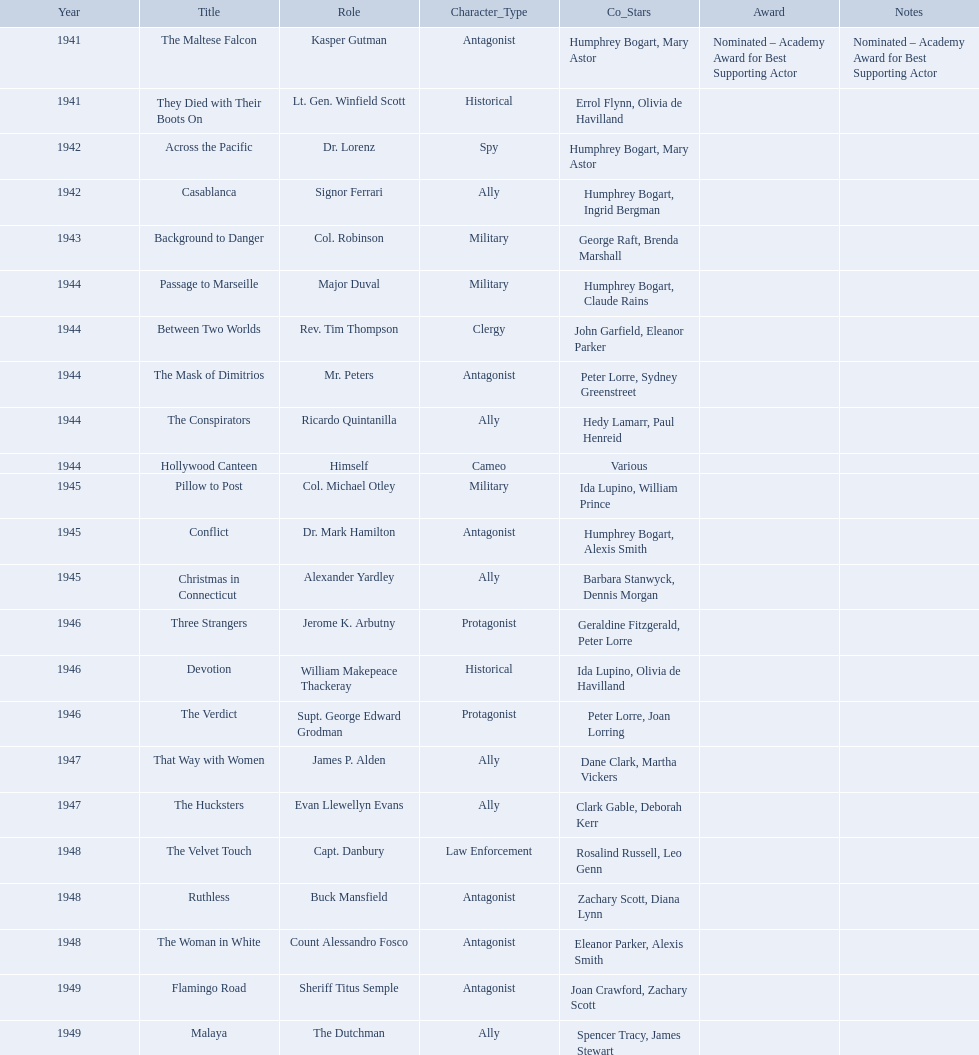What are all of the movies sydney greenstreet acted in? The Maltese Falcon, They Died with Their Boots On, Across the Pacific, Casablanca, Background to Danger, Passage to Marseille, Between Two Worlds, The Mask of Dimitrios, The Conspirators, Hollywood Canteen, Pillow to Post, Conflict, Christmas in Connecticut, Three Strangers, Devotion, The Verdict, That Way with Women, The Hucksters, The Velvet Touch, Ruthless, The Woman in White, Flamingo Road, Malaya. What are all of the title notes? Nominated – Academy Award for Best Supporting Actor. Could you parse the entire table? {'header': ['Year', 'Title', 'Role', 'Character_Type', 'Co_Stars', 'Award', 'Notes'], 'rows': [['1941', 'The Maltese Falcon', 'Kasper Gutman', 'Antagonist', 'Humphrey Bogart, Mary Astor', 'Nominated – Academy Award for Best Supporting Actor', 'Nominated – Academy Award for Best Supporting Actor'], ['1941', 'They Died with Their Boots On', 'Lt. Gen. Winfield Scott', 'Historical', 'Errol Flynn, Olivia de Havilland', '', ''], ['1942', 'Across the Pacific', 'Dr. Lorenz', 'Spy', 'Humphrey Bogart, Mary Astor', '', ''], ['1942', 'Casablanca', 'Signor Ferrari', 'Ally', 'Humphrey Bogart, Ingrid Bergman', '', ''], ['1943', 'Background to Danger', 'Col. Robinson', 'Military', 'George Raft, Brenda Marshall', '', ''], ['1944', 'Passage to Marseille', 'Major Duval', 'Military', 'Humphrey Bogart, Claude Rains', '', ''], ['1944', 'Between Two Worlds', 'Rev. Tim Thompson', 'Clergy', 'John Garfield, Eleanor Parker', '', ''], ['1944', 'The Mask of Dimitrios', 'Mr. Peters', 'Antagonist', 'Peter Lorre, Sydney Greenstreet', '', ''], ['1944', 'The Conspirators', 'Ricardo Quintanilla', 'Ally', 'Hedy Lamarr, Paul Henreid', '', ''], ['1944', 'Hollywood Canteen', 'Himself', 'Cameo', 'Various', '', ''], ['1945', 'Pillow to Post', 'Col. Michael Otley', 'Military', 'Ida Lupino, William Prince', '', ''], ['1945', 'Conflict', 'Dr. Mark Hamilton', 'Antagonist', 'Humphrey Bogart, Alexis Smith', '', ''], ['1945', 'Christmas in Connecticut', 'Alexander Yardley', 'Ally', 'Barbara Stanwyck, Dennis Morgan', '', ''], ['1946', 'Three Strangers', 'Jerome K. Arbutny', 'Protagonist', 'Geraldine Fitzgerald, Peter Lorre', '', ''], ['1946', 'Devotion', 'William Makepeace Thackeray', 'Historical', 'Ida Lupino, Olivia de Havilland', '', ''], ['1946', 'The Verdict', 'Supt. George Edward Grodman', 'Protagonist', 'Peter Lorre, Joan Lorring', '', ''], ['1947', 'That Way with Women', 'James P. Alden', 'Ally', 'Dane Clark, Martha Vickers', '', ''], ['1947', 'The Hucksters', 'Evan Llewellyn Evans', 'Ally', 'Clark Gable, Deborah Kerr', '', ''], ['1948', 'The Velvet Touch', 'Capt. Danbury', 'Law Enforcement', 'Rosalind Russell, Leo Genn', '', ''], ['1948', 'Ruthless', 'Buck Mansfield', 'Antagonist', 'Zachary Scott, Diana Lynn', '', ''], ['1948', 'The Woman in White', 'Count Alessandro Fosco', 'Antagonist', 'Eleanor Parker, Alexis Smith', '', ''], ['1949', 'Flamingo Road', 'Sheriff Titus Semple', 'Antagonist', 'Joan Crawford, Zachary Scott', '', ''], ['1949', 'Malaya', 'The Dutchman', 'Ally', 'Spencer Tracy, James Stewart', '', '']]} Which film was the award for? The Maltese Falcon. What are the movies? The Maltese Falcon, They Died with Their Boots On, Across the Pacific, Casablanca, Background to Danger, Passage to Marseille, Between Two Worlds, The Mask of Dimitrios, The Conspirators, Hollywood Canteen, Pillow to Post, Conflict, Christmas in Connecticut, Three Strangers, Devotion, The Verdict, That Way with Women, The Hucksters, The Velvet Touch, Ruthless, The Woman in White, Flamingo Road, Malaya. Of these, for which did he get nominated for an oscar? The Maltese Falcon. 